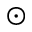Convert formula to latex. <formula><loc_0><loc_0><loc_500><loc_500>\odot</formula> 